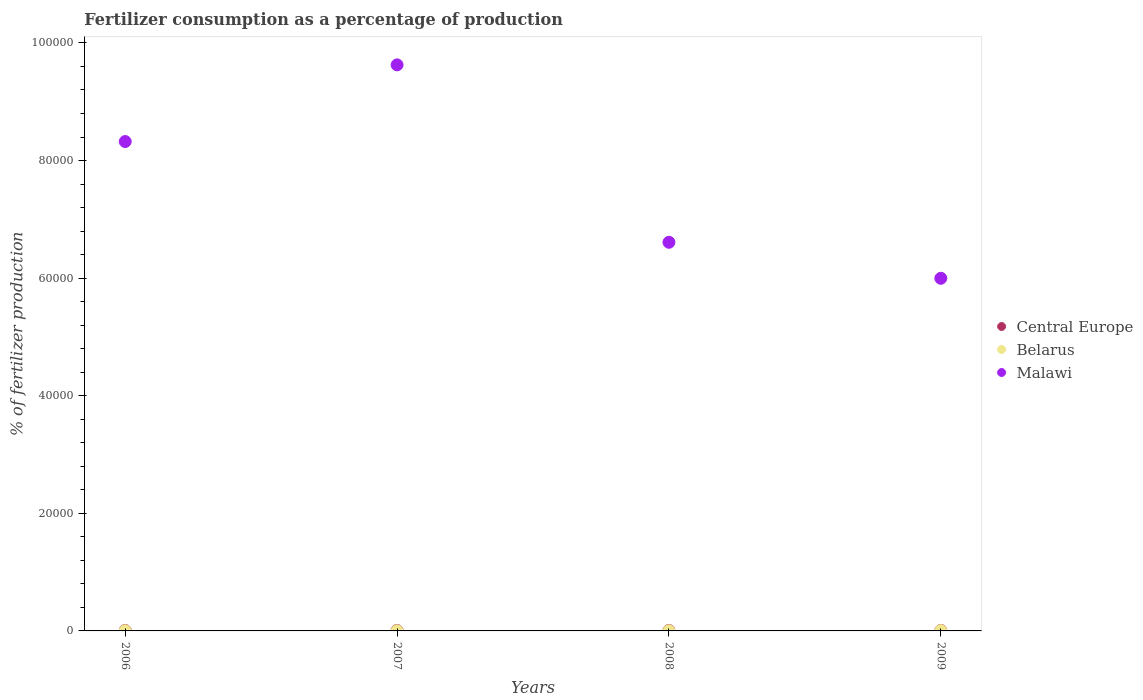What is the percentage of fertilizers consumed in Malawi in 2007?
Ensure brevity in your answer.  9.63e+04. Across all years, what is the maximum percentage of fertilizers consumed in Malawi?
Ensure brevity in your answer.  9.63e+04. Across all years, what is the minimum percentage of fertilizers consumed in Malawi?
Provide a succinct answer. 6.00e+04. In which year was the percentage of fertilizers consumed in Malawi minimum?
Offer a very short reply. 2009. What is the total percentage of fertilizers consumed in Malawi in the graph?
Offer a terse response. 3.06e+05. What is the difference between the percentage of fertilizers consumed in Central Europe in 2007 and that in 2009?
Offer a terse response. -4.69. What is the difference between the percentage of fertilizers consumed in Malawi in 2008 and the percentage of fertilizers consumed in Belarus in 2009?
Your answer should be very brief. 6.61e+04. What is the average percentage of fertilizers consumed in Central Europe per year?
Keep it short and to the point. 72.06. In the year 2006, what is the difference between the percentage of fertilizers consumed in Central Europe and percentage of fertilizers consumed in Malawi?
Your answer should be compact. -8.32e+04. In how many years, is the percentage of fertilizers consumed in Central Europe greater than 48000 %?
Provide a succinct answer. 0. What is the ratio of the percentage of fertilizers consumed in Central Europe in 2007 to that in 2008?
Keep it short and to the point. 1.03. Is the percentage of fertilizers consumed in Malawi in 2006 less than that in 2009?
Your answer should be very brief. No. Is the difference between the percentage of fertilizers consumed in Central Europe in 2007 and 2008 greater than the difference between the percentage of fertilizers consumed in Malawi in 2007 and 2008?
Your answer should be very brief. No. What is the difference between the highest and the second highest percentage of fertilizers consumed in Malawi?
Provide a short and direct response. 1.30e+04. What is the difference between the highest and the lowest percentage of fertilizers consumed in Belarus?
Provide a short and direct response. 26.58. Is the sum of the percentage of fertilizers consumed in Malawi in 2006 and 2008 greater than the maximum percentage of fertilizers consumed in Central Europe across all years?
Offer a very short reply. Yes. Is it the case that in every year, the sum of the percentage of fertilizers consumed in Central Europe and percentage of fertilizers consumed in Malawi  is greater than the percentage of fertilizers consumed in Belarus?
Ensure brevity in your answer.  Yes. Is the percentage of fertilizers consumed in Malawi strictly greater than the percentage of fertilizers consumed in Belarus over the years?
Your answer should be compact. Yes. Is the percentage of fertilizers consumed in Belarus strictly less than the percentage of fertilizers consumed in Central Europe over the years?
Your answer should be very brief. Yes. How many years are there in the graph?
Offer a terse response. 4. What is the difference between two consecutive major ticks on the Y-axis?
Your answer should be compact. 2.00e+04. Are the values on the major ticks of Y-axis written in scientific E-notation?
Ensure brevity in your answer.  No. How many legend labels are there?
Your answer should be compact. 3. How are the legend labels stacked?
Offer a very short reply. Vertical. What is the title of the graph?
Keep it short and to the point. Fertilizer consumption as a percentage of production. What is the label or title of the Y-axis?
Ensure brevity in your answer.  % of fertilizer production. What is the % of fertilizer production of Central Europe in 2006?
Provide a succinct answer. 69.24. What is the % of fertilizer production of Belarus in 2006?
Provide a succinct answer. 23.69. What is the % of fertilizer production of Malawi in 2006?
Your answer should be very brief. 8.32e+04. What is the % of fertilizer production of Central Europe in 2007?
Provide a short and direct response. 72.07. What is the % of fertilizer production of Belarus in 2007?
Your answer should be very brief. 20.09. What is the % of fertilizer production in Malawi in 2007?
Keep it short and to the point. 9.63e+04. What is the % of fertilizer production in Central Europe in 2008?
Offer a terse response. 70.16. What is the % of fertilizer production of Belarus in 2008?
Provide a short and direct response. 21.95. What is the % of fertilizer production in Malawi in 2008?
Your answer should be very brief. 6.61e+04. What is the % of fertilizer production of Central Europe in 2009?
Give a very brief answer. 76.75. What is the % of fertilizer production in Belarus in 2009?
Provide a short and direct response. 46.67. What is the % of fertilizer production of Malawi in 2009?
Provide a short and direct response. 6.00e+04. Across all years, what is the maximum % of fertilizer production of Central Europe?
Provide a short and direct response. 76.75. Across all years, what is the maximum % of fertilizer production of Belarus?
Offer a terse response. 46.67. Across all years, what is the maximum % of fertilizer production in Malawi?
Your answer should be very brief. 9.63e+04. Across all years, what is the minimum % of fertilizer production of Central Europe?
Offer a terse response. 69.24. Across all years, what is the minimum % of fertilizer production in Belarus?
Offer a very short reply. 20.09. Across all years, what is the minimum % of fertilizer production of Malawi?
Keep it short and to the point. 6.00e+04. What is the total % of fertilizer production of Central Europe in the graph?
Offer a very short reply. 288.22. What is the total % of fertilizer production of Belarus in the graph?
Provide a succinct answer. 112.38. What is the total % of fertilizer production of Malawi in the graph?
Give a very brief answer. 3.06e+05. What is the difference between the % of fertilizer production of Central Europe in 2006 and that in 2007?
Your answer should be compact. -2.82. What is the difference between the % of fertilizer production of Belarus in 2006 and that in 2007?
Provide a short and direct response. 3.6. What is the difference between the % of fertilizer production in Malawi in 2006 and that in 2007?
Your answer should be compact. -1.30e+04. What is the difference between the % of fertilizer production of Central Europe in 2006 and that in 2008?
Make the answer very short. -0.92. What is the difference between the % of fertilizer production in Belarus in 2006 and that in 2008?
Keep it short and to the point. 1.74. What is the difference between the % of fertilizer production in Malawi in 2006 and that in 2008?
Provide a succinct answer. 1.71e+04. What is the difference between the % of fertilizer production in Central Europe in 2006 and that in 2009?
Your answer should be very brief. -7.51. What is the difference between the % of fertilizer production of Belarus in 2006 and that in 2009?
Your answer should be very brief. -22.98. What is the difference between the % of fertilizer production of Malawi in 2006 and that in 2009?
Ensure brevity in your answer.  2.33e+04. What is the difference between the % of fertilizer production of Central Europe in 2007 and that in 2008?
Your response must be concise. 1.9. What is the difference between the % of fertilizer production of Belarus in 2007 and that in 2008?
Give a very brief answer. -1.86. What is the difference between the % of fertilizer production of Malawi in 2007 and that in 2008?
Provide a succinct answer. 3.02e+04. What is the difference between the % of fertilizer production of Central Europe in 2007 and that in 2009?
Offer a terse response. -4.69. What is the difference between the % of fertilizer production in Belarus in 2007 and that in 2009?
Provide a short and direct response. -26.58. What is the difference between the % of fertilizer production of Malawi in 2007 and that in 2009?
Give a very brief answer. 3.63e+04. What is the difference between the % of fertilizer production in Central Europe in 2008 and that in 2009?
Provide a succinct answer. -6.59. What is the difference between the % of fertilizer production of Belarus in 2008 and that in 2009?
Keep it short and to the point. -24.72. What is the difference between the % of fertilizer production in Malawi in 2008 and that in 2009?
Offer a very short reply. 6122.77. What is the difference between the % of fertilizer production of Central Europe in 2006 and the % of fertilizer production of Belarus in 2007?
Your answer should be compact. 49.16. What is the difference between the % of fertilizer production of Central Europe in 2006 and the % of fertilizer production of Malawi in 2007?
Give a very brief answer. -9.62e+04. What is the difference between the % of fertilizer production of Belarus in 2006 and the % of fertilizer production of Malawi in 2007?
Keep it short and to the point. -9.63e+04. What is the difference between the % of fertilizer production of Central Europe in 2006 and the % of fertilizer production of Belarus in 2008?
Offer a very short reply. 47.3. What is the difference between the % of fertilizer production in Central Europe in 2006 and the % of fertilizer production in Malawi in 2008?
Your answer should be compact. -6.60e+04. What is the difference between the % of fertilizer production of Belarus in 2006 and the % of fertilizer production of Malawi in 2008?
Make the answer very short. -6.61e+04. What is the difference between the % of fertilizer production in Central Europe in 2006 and the % of fertilizer production in Belarus in 2009?
Provide a short and direct response. 22.58. What is the difference between the % of fertilizer production of Central Europe in 2006 and the % of fertilizer production of Malawi in 2009?
Make the answer very short. -5.99e+04. What is the difference between the % of fertilizer production in Belarus in 2006 and the % of fertilizer production in Malawi in 2009?
Provide a succinct answer. -6.00e+04. What is the difference between the % of fertilizer production in Central Europe in 2007 and the % of fertilizer production in Belarus in 2008?
Your answer should be very brief. 50.12. What is the difference between the % of fertilizer production in Central Europe in 2007 and the % of fertilizer production in Malawi in 2008?
Offer a terse response. -6.60e+04. What is the difference between the % of fertilizer production of Belarus in 2007 and the % of fertilizer production of Malawi in 2008?
Give a very brief answer. -6.61e+04. What is the difference between the % of fertilizer production in Central Europe in 2007 and the % of fertilizer production in Belarus in 2009?
Offer a terse response. 25.4. What is the difference between the % of fertilizer production in Central Europe in 2007 and the % of fertilizer production in Malawi in 2009?
Provide a short and direct response. -5.99e+04. What is the difference between the % of fertilizer production of Belarus in 2007 and the % of fertilizer production of Malawi in 2009?
Your answer should be compact. -6.00e+04. What is the difference between the % of fertilizer production in Central Europe in 2008 and the % of fertilizer production in Belarus in 2009?
Ensure brevity in your answer.  23.5. What is the difference between the % of fertilizer production of Central Europe in 2008 and the % of fertilizer production of Malawi in 2009?
Offer a terse response. -5.99e+04. What is the difference between the % of fertilizer production of Belarus in 2008 and the % of fertilizer production of Malawi in 2009?
Keep it short and to the point. -6.00e+04. What is the average % of fertilizer production of Central Europe per year?
Provide a succinct answer. 72.06. What is the average % of fertilizer production in Belarus per year?
Provide a succinct answer. 28.1. What is the average % of fertilizer production of Malawi per year?
Your response must be concise. 7.64e+04. In the year 2006, what is the difference between the % of fertilizer production in Central Europe and % of fertilizer production in Belarus?
Give a very brief answer. 45.56. In the year 2006, what is the difference between the % of fertilizer production in Central Europe and % of fertilizer production in Malawi?
Give a very brief answer. -8.32e+04. In the year 2006, what is the difference between the % of fertilizer production of Belarus and % of fertilizer production of Malawi?
Your answer should be very brief. -8.32e+04. In the year 2007, what is the difference between the % of fertilizer production of Central Europe and % of fertilizer production of Belarus?
Ensure brevity in your answer.  51.98. In the year 2007, what is the difference between the % of fertilizer production of Central Europe and % of fertilizer production of Malawi?
Offer a very short reply. -9.62e+04. In the year 2007, what is the difference between the % of fertilizer production in Belarus and % of fertilizer production in Malawi?
Keep it short and to the point. -9.63e+04. In the year 2008, what is the difference between the % of fertilizer production in Central Europe and % of fertilizer production in Belarus?
Offer a terse response. 48.22. In the year 2008, what is the difference between the % of fertilizer production of Central Europe and % of fertilizer production of Malawi?
Offer a terse response. -6.60e+04. In the year 2008, what is the difference between the % of fertilizer production in Belarus and % of fertilizer production in Malawi?
Ensure brevity in your answer.  -6.61e+04. In the year 2009, what is the difference between the % of fertilizer production in Central Europe and % of fertilizer production in Belarus?
Give a very brief answer. 30.09. In the year 2009, what is the difference between the % of fertilizer production of Central Europe and % of fertilizer production of Malawi?
Give a very brief answer. -5.99e+04. In the year 2009, what is the difference between the % of fertilizer production in Belarus and % of fertilizer production in Malawi?
Provide a short and direct response. -5.99e+04. What is the ratio of the % of fertilizer production in Central Europe in 2006 to that in 2007?
Provide a succinct answer. 0.96. What is the ratio of the % of fertilizer production of Belarus in 2006 to that in 2007?
Your response must be concise. 1.18. What is the ratio of the % of fertilizer production of Malawi in 2006 to that in 2007?
Keep it short and to the point. 0.86. What is the ratio of the % of fertilizer production in Central Europe in 2006 to that in 2008?
Provide a succinct answer. 0.99. What is the ratio of the % of fertilizer production of Belarus in 2006 to that in 2008?
Your response must be concise. 1.08. What is the ratio of the % of fertilizer production in Malawi in 2006 to that in 2008?
Make the answer very short. 1.26. What is the ratio of the % of fertilizer production of Central Europe in 2006 to that in 2009?
Ensure brevity in your answer.  0.9. What is the ratio of the % of fertilizer production of Belarus in 2006 to that in 2009?
Your answer should be very brief. 0.51. What is the ratio of the % of fertilizer production of Malawi in 2006 to that in 2009?
Your response must be concise. 1.39. What is the ratio of the % of fertilizer production in Central Europe in 2007 to that in 2008?
Provide a succinct answer. 1.03. What is the ratio of the % of fertilizer production in Belarus in 2007 to that in 2008?
Make the answer very short. 0.92. What is the ratio of the % of fertilizer production in Malawi in 2007 to that in 2008?
Give a very brief answer. 1.46. What is the ratio of the % of fertilizer production in Central Europe in 2007 to that in 2009?
Offer a very short reply. 0.94. What is the ratio of the % of fertilizer production in Belarus in 2007 to that in 2009?
Provide a short and direct response. 0.43. What is the ratio of the % of fertilizer production of Malawi in 2007 to that in 2009?
Your response must be concise. 1.61. What is the ratio of the % of fertilizer production of Central Europe in 2008 to that in 2009?
Keep it short and to the point. 0.91. What is the ratio of the % of fertilizer production of Belarus in 2008 to that in 2009?
Your answer should be very brief. 0.47. What is the ratio of the % of fertilizer production of Malawi in 2008 to that in 2009?
Keep it short and to the point. 1.1. What is the difference between the highest and the second highest % of fertilizer production of Central Europe?
Keep it short and to the point. 4.69. What is the difference between the highest and the second highest % of fertilizer production in Belarus?
Your answer should be very brief. 22.98. What is the difference between the highest and the second highest % of fertilizer production in Malawi?
Provide a succinct answer. 1.30e+04. What is the difference between the highest and the lowest % of fertilizer production in Central Europe?
Ensure brevity in your answer.  7.51. What is the difference between the highest and the lowest % of fertilizer production of Belarus?
Provide a succinct answer. 26.58. What is the difference between the highest and the lowest % of fertilizer production in Malawi?
Ensure brevity in your answer.  3.63e+04. 